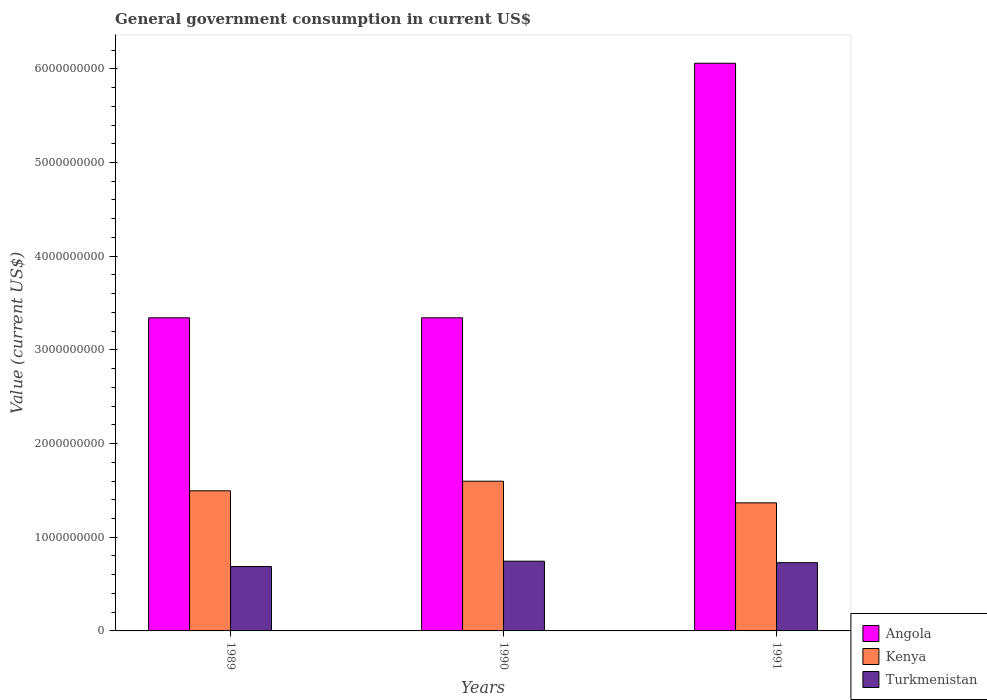How many groups of bars are there?
Give a very brief answer. 3. Are the number of bars per tick equal to the number of legend labels?
Provide a succinct answer. Yes. Are the number of bars on each tick of the X-axis equal?
Provide a succinct answer. Yes. How many bars are there on the 2nd tick from the left?
Your answer should be compact. 3. How many bars are there on the 1st tick from the right?
Offer a terse response. 3. What is the label of the 2nd group of bars from the left?
Your answer should be compact. 1990. What is the government conusmption in Turkmenistan in 1989?
Your response must be concise. 6.87e+08. Across all years, what is the maximum government conusmption in Kenya?
Your response must be concise. 1.60e+09. Across all years, what is the minimum government conusmption in Turkmenistan?
Provide a succinct answer. 6.87e+08. In which year was the government conusmption in Turkmenistan maximum?
Your answer should be very brief. 1990. In which year was the government conusmption in Kenya minimum?
Give a very brief answer. 1991. What is the total government conusmption in Kenya in the graph?
Ensure brevity in your answer.  4.46e+09. What is the difference between the government conusmption in Kenya in 1989 and that in 1991?
Your answer should be compact. 1.29e+08. What is the difference between the government conusmption in Kenya in 1991 and the government conusmption in Angola in 1990?
Ensure brevity in your answer.  -1.98e+09. What is the average government conusmption in Kenya per year?
Your response must be concise. 1.49e+09. In the year 1989, what is the difference between the government conusmption in Turkmenistan and government conusmption in Kenya?
Keep it short and to the point. -8.08e+08. What is the ratio of the government conusmption in Angola in 1990 to that in 1991?
Provide a short and direct response. 0.55. Is the difference between the government conusmption in Turkmenistan in 1989 and 1991 greater than the difference between the government conusmption in Kenya in 1989 and 1991?
Offer a terse response. No. What is the difference between the highest and the second highest government conusmption in Kenya?
Give a very brief answer. 1.02e+08. What is the difference between the highest and the lowest government conusmption in Turkmenistan?
Keep it short and to the point. 5.69e+07. What does the 1st bar from the left in 1991 represents?
Offer a terse response. Angola. What does the 2nd bar from the right in 1991 represents?
Your answer should be compact. Kenya. How many bars are there?
Ensure brevity in your answer.  9. What is the difference between two consecutive major ticks on the Y-axis?
Your answer should be very brief. 1.00e+09. Are the values on the major ticks of Y-axis written in scientific E-notation?
Your answer should be compact. No. Does the graph contain grids?
Provide a succinct answer. No. What is the title of the graph?
Provide a succinct answer. General government consumption in current US$. Does "Congo (Republic)" appear as one of the legend labels in the graph?
Give a very brief answer. No. What is the label or title of the X-axis?
Your answer should be compact. Years. What is the label or title of the Y-axis?
Make the answer very short. Value (current US$). What is the Value (current US$) of Angola in 1989?
Your response must be concise. 3.34e+09. What is the Value (current US$) in Kenya in 1989?
Give a very brief answer. 1.50e+09. What is the Value (current US$) of Turkmenistan in 1989?
Ensure brevity in your answer.  6.87e+08. What is the Value (current US$) of Angola in 1990?
Provide a short and direct response. 3.34e+09. What is the Value (current US$) in Kenya in 1990?
Your answer should be very brief. 1.60e+09. What is the Value (current US$) in Turkmenistan in 1990?
Your response must be concise. 7.44e+08. What is the Value (current US$) of Angola in 1991?
Your answer should be very brief. 6.06e+09. What is the Value (current US$) in Kenya in 1991?
Keep it short and to the point. 1.37e+09. What is the Value (current US$) of Turkmenistan in 1991?
Keep it short and to the point. 7.29e+08. Across all years, what is the maximum Value (current US$) of Angola?
Offer a terse response. 6.06e+09. Across all years, what is the maximum Value (current US$) of Kenya?
Provide a short and direct response. 1.60e+09. Across all years, what is the maximum Value (current US$) of Turkmenistan?
Make the answer very short. 7.44e+08. Across all years, what is the minimum Value (current US$) in Angola?
Make the answer very short. 3.34e+09. Across all years, what is the minimum Value (current US$) in Kenya?
Offer a very short reply. 1.37e+09. Across all years, what is the minimum Value (current US$) in Turkmenistan?
Provide a short and direct response. 6.87e+08. What is the total Value (current US$) of Angola in the graph?
Ensure brevity in your answer.  1.27e+1. What is the total Value (current US$) of Kenya in the graph?
Make the answer very short. 4.46e+09. What is the total Value (current US$) in Turkmenistan in the graph?
Provide a succinct answer. 2.16e+09. What is the difference between the Value (current US$) of Kenya in 1989 and that in 1990?
Make the answer very short. -1.02e+08. What is the difference between the Value (current US$) of Turkmenistan in 1989 and that in 1990?
Your answer should be compact. -5.69e+07. What is the difference between the Value (current US$) in Angola in 1989 and that in 1991?
Give a very brief answer. -2.72e+09. What is the difference between the Value (current US$) of Kenya in 1989 and that in 1991?
Your answer should be very brief. 1.29e+08. What is the difference between the Value (current US$) in Turkmenistan in 1989 and that in 1991?
Your answer should be very brief. -4.13e+07. What is the difference between the Value (current US$) in Angola in 1990 and that in 1991?
Give a very brief answer. -2.72e+09. What is the difference between the Value (current US$) in Kenya in 1990 and that in 1991?
Your response must be concise. 2.31e+08. What is the difference between the Value (current US$) of Turkmenistan in 1990 and that in 1991?
Your answer should be very brief. 1.56e+07. What is the difference between the Value (current US$) in Angola in 1989 and the Value (current US$) in Kenya in 1990?
Ensure brevity in your answer.  1.74e+09. What is the difference between the Value (current US$) of Angola in 1989 and the Value (current US$) of Turkmenistan in 1990?
Offer a very short reply. 2.60e+09. What is the difference between the Value (current US$) in Kenya in 1989 and the Value (current US$) in Turkmenistan in 1990?
Provide a succinct answer. 7.51e+08. What is the difference between the Value (current US$) in Angola in 1989 and the Value (current US$) in Kenya in 1991?
Make the answer very short. 1.98e+09. What is the difference between the Value (current US$) of Angola in 1989 and the Value (current US$) of Turkmenistan in 1991?
Your answer should be compact. 2.61e+09. What is the difference between the Value (current US$) of Kenya in 1989 and the Value (current US$) of Turkmenistan in 1991?
Provide a succinct answer. 7.67e+08. What is the difference between the Value (current US$) in Angola in 1990 and the Value (current US$) in Kenya in 1991?
Offer a very short reply. 1.98e+09. What is the difference between the Value (current US$) in Angola in 1990 and the Value (current US$) in Turkmenistan in 1991?
Your answer should be very brief. 2.61e+09. What is the difference between the Value (current US$) in Kenya in 1990 and the Value (current US$) in Turkmenistan in 1991?
Offer a very short reply. 8.69e+08. What is the average Value (current US$) in Angola per year?
Make the answer very short. 4.25e+09. What is the average Value (current US$) of Kenya per year?
Ensure brevity in your answer.  1.49e+09. What is the average Value (current US$) of Turkmenistan per year?
Your response must be concise. 7.20e+08. In the year 1989, what is the difference between the Value (current US$) of Angola and Value (current US$) of Kenya?
Your answer should be compact. 1.85e+09. In the year 1989, what is the difference between the Value (current US$) of Angola and Value (current US$) of Turkmenistan?
Keep it short and to the point. 2.65e+09. In the year 1989, what is the difference between the Value (current US$) in Kenya and Value (current US$) in Turkmenistan?
Your response must be concise. 8.08e+08. In the year 1990, what is the difference between the Value (current US$) in Angola and Value (current US$) in Kenya?
Give a very brief answer. 1.74e+09. In the year 1990, what is the difference between the Value (current US$) in Angola and Value (current US$) in Turkmenistan?
Provide a succinct answer. 2.60e+09. In the year 1990, what is the difference between the Value (current US$) in Kenya and Value (current US$) in Turkmenistan?
Offer a terse response. 8.54e+08. In the year 1991, what is the difference between the Value (current US$) in Angola and Value (current US$) in Kenya?
Give a very brief answer. 4.69e+09. In the year 1991, what is the difference between the Value (current US$) of Angola and Value (current US$) of Turkmenistan?
Keep it short and to the point. 5.33e+09. In the year 1991, what is the difference between the Value (current US$) in Kenya and Value (current US$) in Turkmenistan?
Your answer should be very brief. 6.38e+08. What is the ratio of the Value (current US$) of Kenya in 1989 to that in 1990?
Your answer should be compact. 0.94. What is the ratio of the Value (current US$) of Turkmenistan in 1989 to that in 1990?
Keep it short and to the point. 0.92. What is the ratio of the Value (current US$) in Angola in 1989 to that in 1991?
Your answer should be compact. 0.55. What is the ratio of the Value (current US$) in Kenya in 1989 to that in 1991?
Provide a succinct answer. 1.09. What is the ratio of the Value (current US$) of Turkmenistan in 1989 to that in 1991?
Keep it short and to the point. 0.94. What is the ratio of the Value (current US$) in Angola in 1990 to that in 1991?
Offer a very short reply. 0.55. What is the ratio of the Value (current US$) of Kenya in 1990 to that in 1991?
Offer a very short reply. 1.17. What is the ratio of the Value (current US$) of Turkmenistan in 1990 to that in 1991?
Provide a succinct answer. 1.02. What is the difference between the highest and the second highest Value (current US$) in Angola?
Your answer should be compact. 2.72e+09. What is the difference between the highest and the second highest Value (current US$) of Kenya?
Your answer should be compact. 1.02e+08. What is the difference between the highest and the second highest Value (current US$) in Turkmenistan?
Offer a very short reply. 1.56e+07. What is the difference between the highest and the lowest Value (current US$) of Angola?
Ensure brevity in your answer.  2.72e+09. What is the difference between the highest and the lowest Value (current US$) in Kenya?
Your response must be concise. 2.31e+08. What is the difference between the highest and the lowest Value (current US$) of Turkmenistan?
Your answer should be very brief. 5.69e+07. 